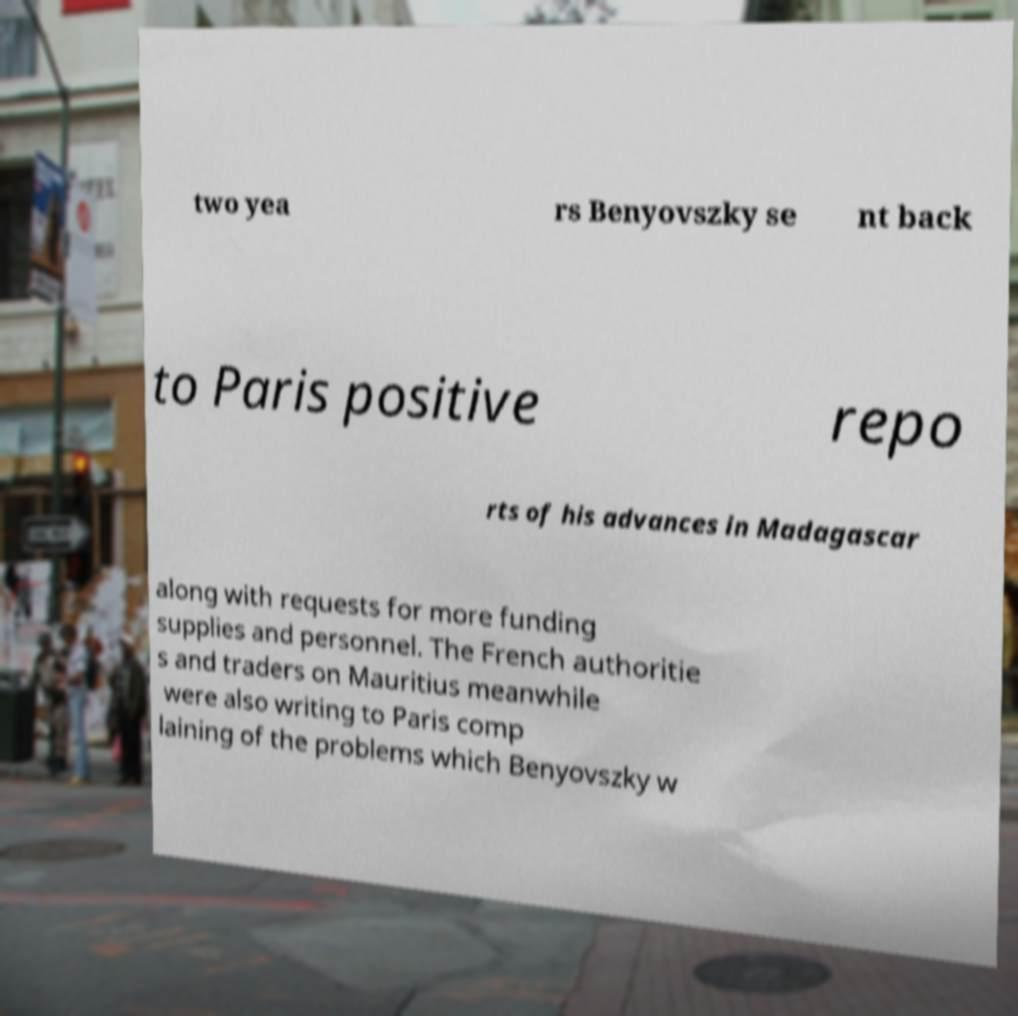Can you accurately transcribe the text from the provided image for me? two yea rs Benyovszky se nt back to Paris positive repo rts of his advances in Madagascar along with requests for more funding supplies and personnel. The French authoritie s and traders on Mauritius meanwhile were also writing to Paris comp laining of the problems which Benyovszky w 